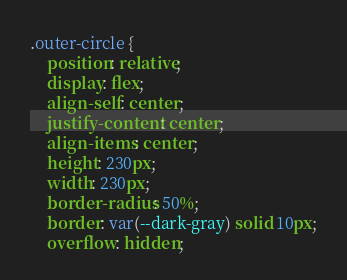Convert code to text. <code><loc_0><loc_0><loc_500><loc_500><_CSS_>.outer-circle {
    position: relative;
    display: flex;
    align-self: center;
    justify-content: center;
    align-items: center;
    height: 230px;
    width: 230px;
    border-radius: 50%;
    border: var(--dark-gray) solid 10px;
    overflow: hidden;</code> 